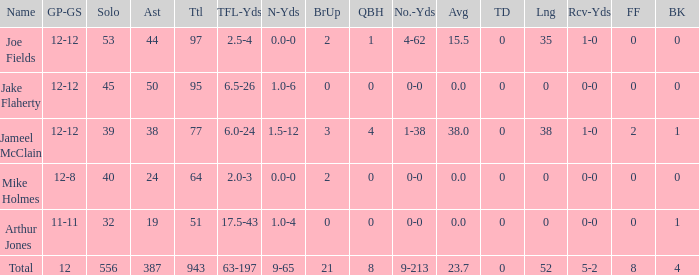What is the total brup for the team? 21.0. 